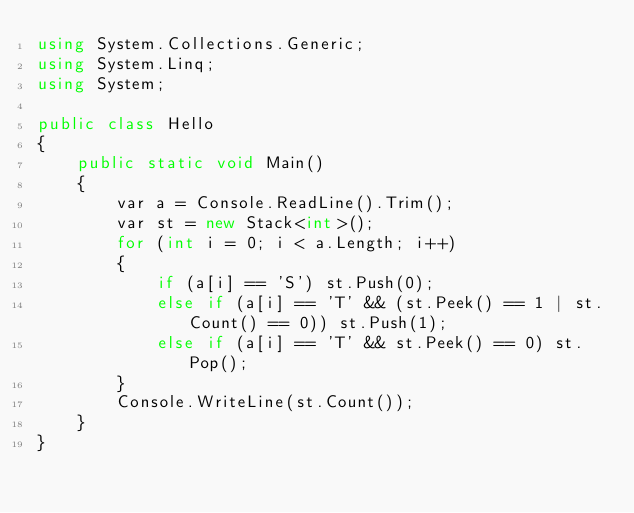<code> <loc_0><loc_0><loc_500><loc_500><_C#_>using System.Collections.Generic;
using System.Linq;
using System;

public class Hello
{
    public static void Main()
    {
        var a = Console.ReadLine().Trim();
        var st = new Stack<int>();
        for (int i = 0; i < a.Length; i++)
        {
            if (a[i] == 'S') st.Push(0);
            else if (a[i] == 'T' && (st.Peek() == 1 | st.Count() == 0)) st.Push(1);
            else if (a[i] == 'T' && st.Peek() == 0) st.Pop();
        }
        Console.WriteLine(st.Count());
    }
}
</code> 